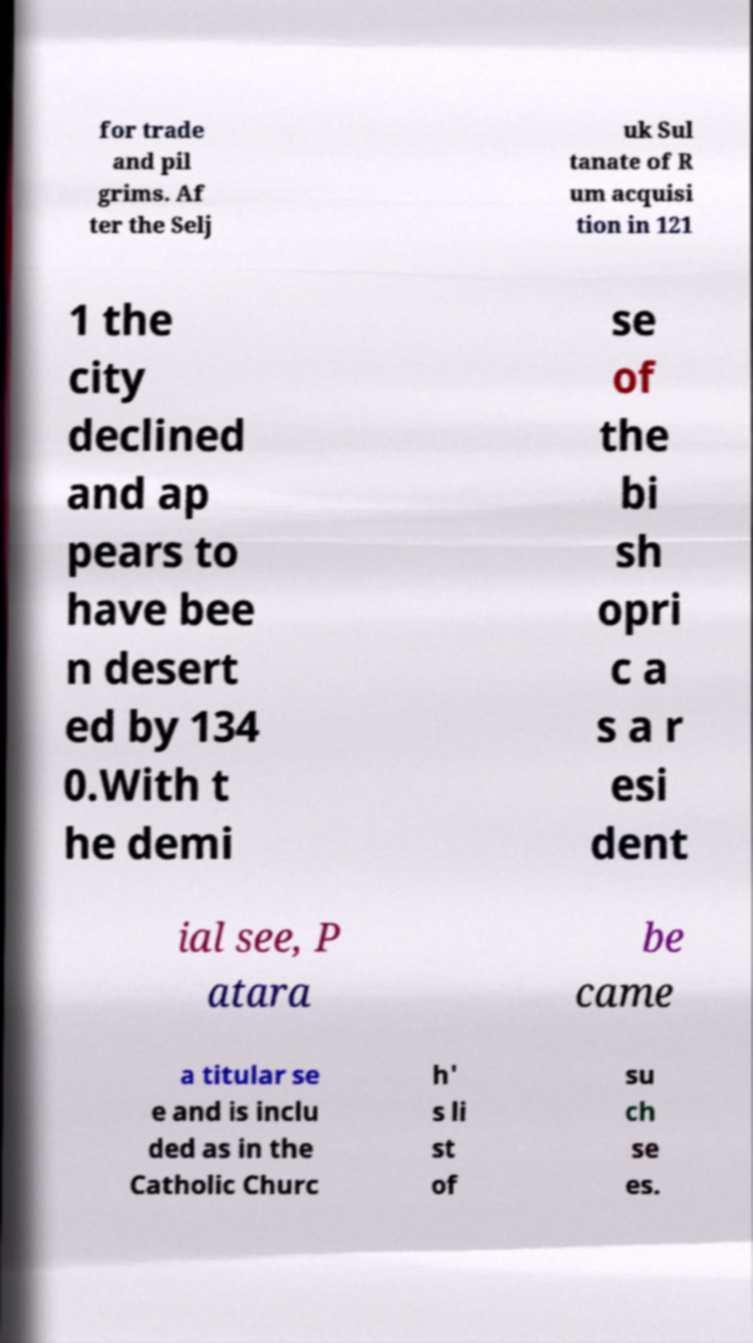Could you extract and type out the text from this image? for trade and pil grims. Af ter the Selj uk Sul tanate of R um acquisi tion in 121 1 the city declined and ap pears to have bee n desert ed by 134 0.With t he demi se of the bi sh opri c a s a r esi dent ial see, P atara be came a titular se e and is inclu ded as in the Catholic Churc h' s li st of su ch se es. 